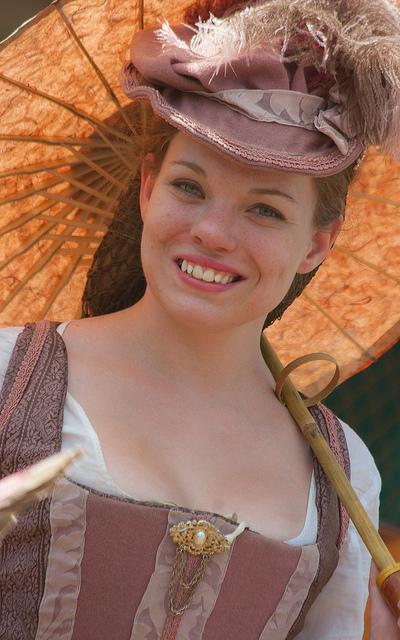Is the woman smiling?
Keep it brief. Yes. Is this woman happy?
Quick response, please. Yes. Is the woman posing for a picture?
Concise answer only. Yes. How many people are shown?
Keep it brief. 1. 